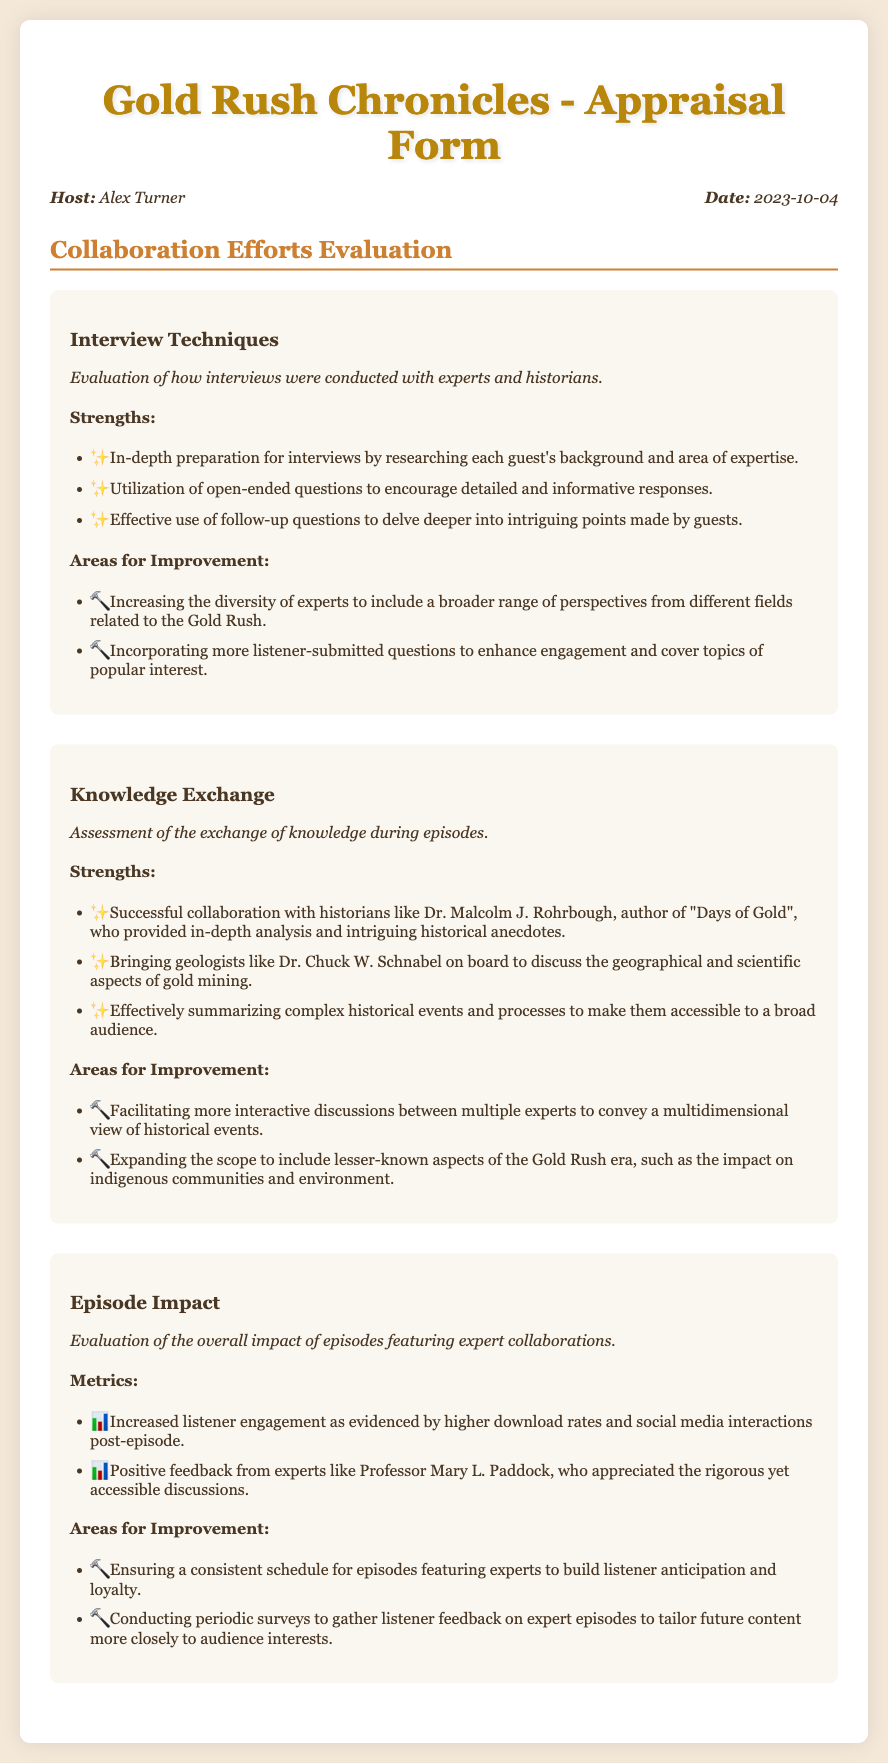What is the name of the host? The host's name is mentioned in the info section of the document.
Answer: Alex Turner What date was the appraisal form completed? The date is included in the same info section alongside the host.
Answer: 2023-10-04 Who is one of the historians mentioned for their contribution? The document lists specific experts that collaborated, one of whom is highlighted.
Answer: Dr. Malcolm J. Rohrbough What is one area for improvement in interview techniques? Areas for improvement are specified in the interview techniques section.
Answer: Increasing the diversity of experts What is one strength of knowledge exchange during episodes? The strengths are listed in the knowledge exchange section of the document.
Answer: Successful collaboration with historians How many metrics were listed under episode impact? The number of metrics relates to the listing presented in the episode impact section.
Answer: 2 What specific feedback did an expert provide? The document includes feedback from experts which signifies the impact of the collaborations.
Answer: Positive feedback from experts What is one suggested area for improvement regarding episode scheduling? The areas for improvement in episode impact mention specific scheduling needs.
Answer: Ensuring a consistent schedule What does the description of episode impact evaluate? The evaluation focus is highlighted clearly in the episode impact section of the document.
Answer: Overall impact of episodes featuring expert collaborations 